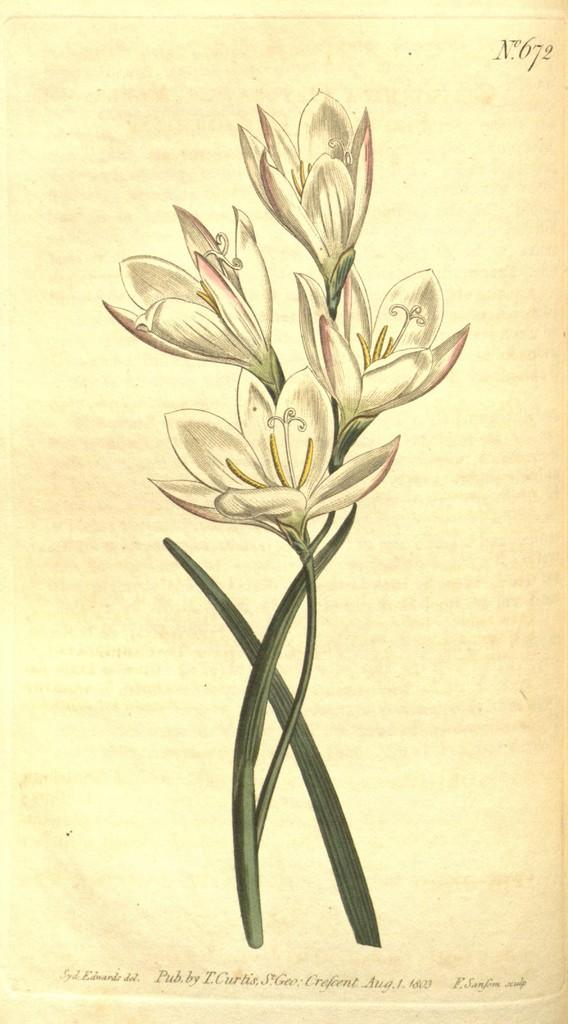What is the main subject of the painting in the image? The main subject of the painting in the image is flowers. What else can be seen in the image besides the painting? There is text in the background of the image. What type of kettle is being used to draw the painting in the image? There is no kettle present in the image, and the painting is not being drawn but rather is a pre-existing artwork. 